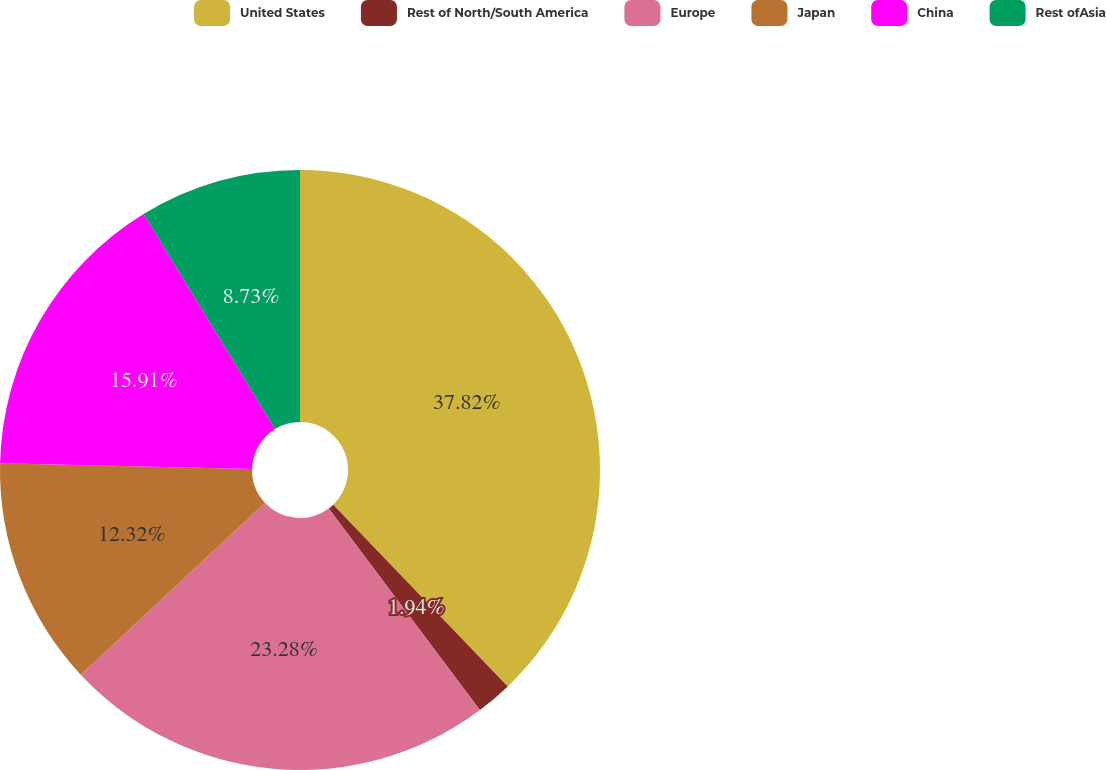<chart> <loc_0><loc_0><loc_500><loc_500><pie_chart><fcel>United States<fcel>Rest of North/South America<fcel>Europe<fcel>Japan<fcel>China<fcel>Rest ofAsia<nl><fcel>37.83%<fcel>1.94%<fcel>23.28%<fcel>12.32%<fcel>15.91%<fcel>8.73%<nl></chart> 